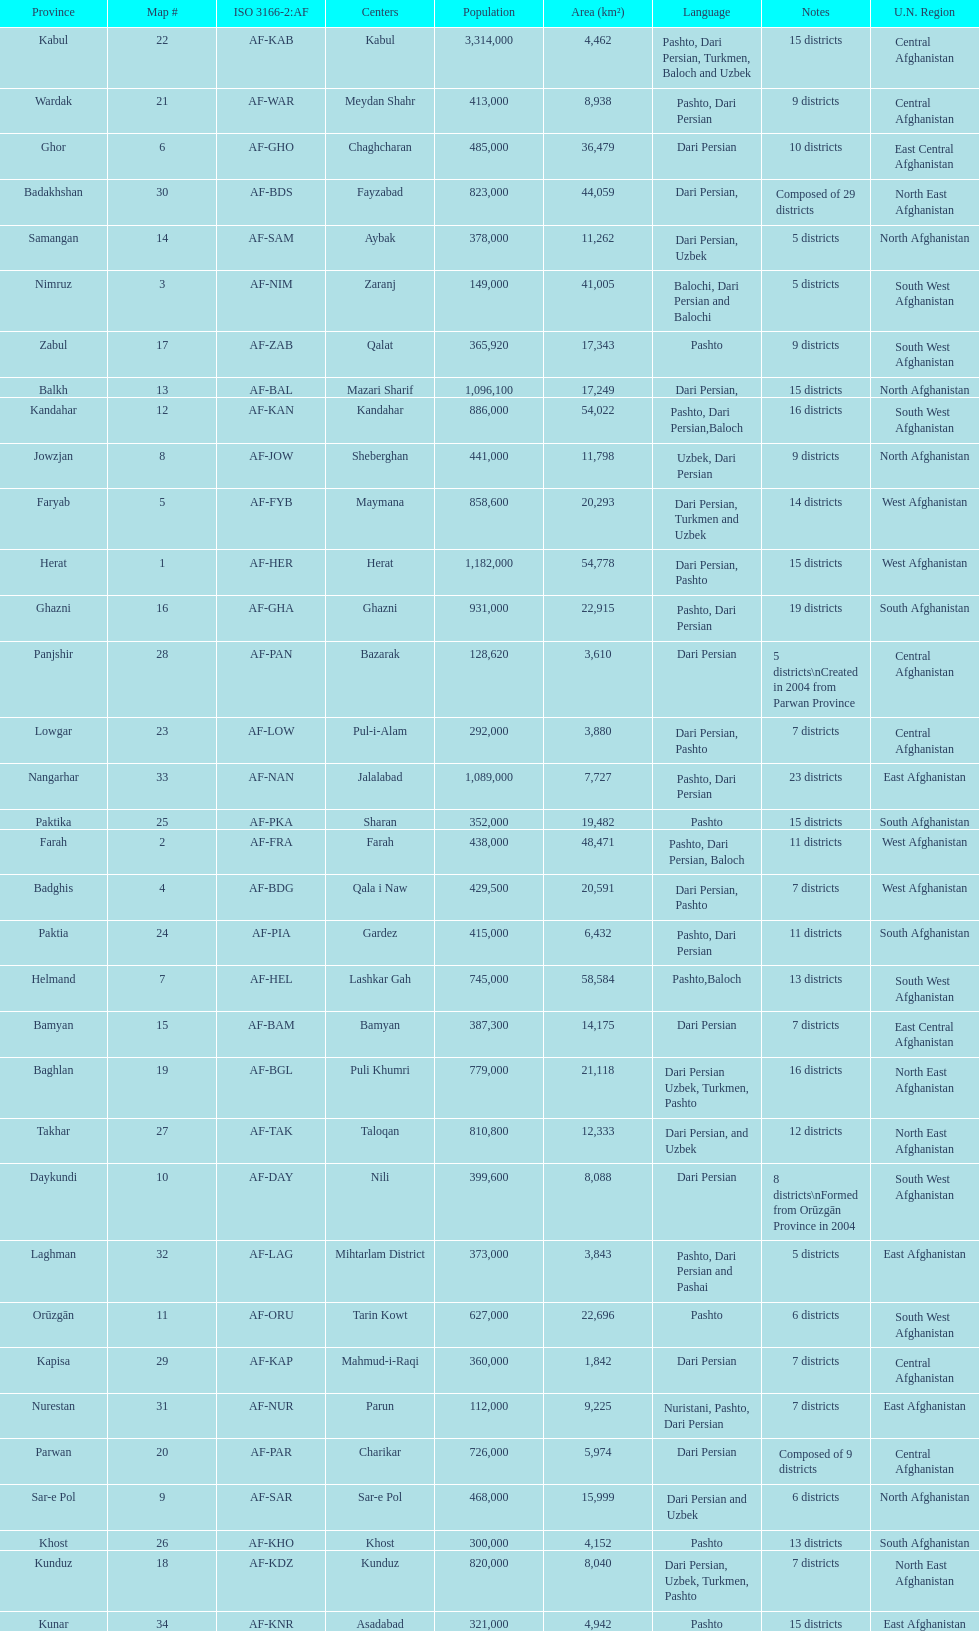How many districts are in the province of kunduz? 7. 